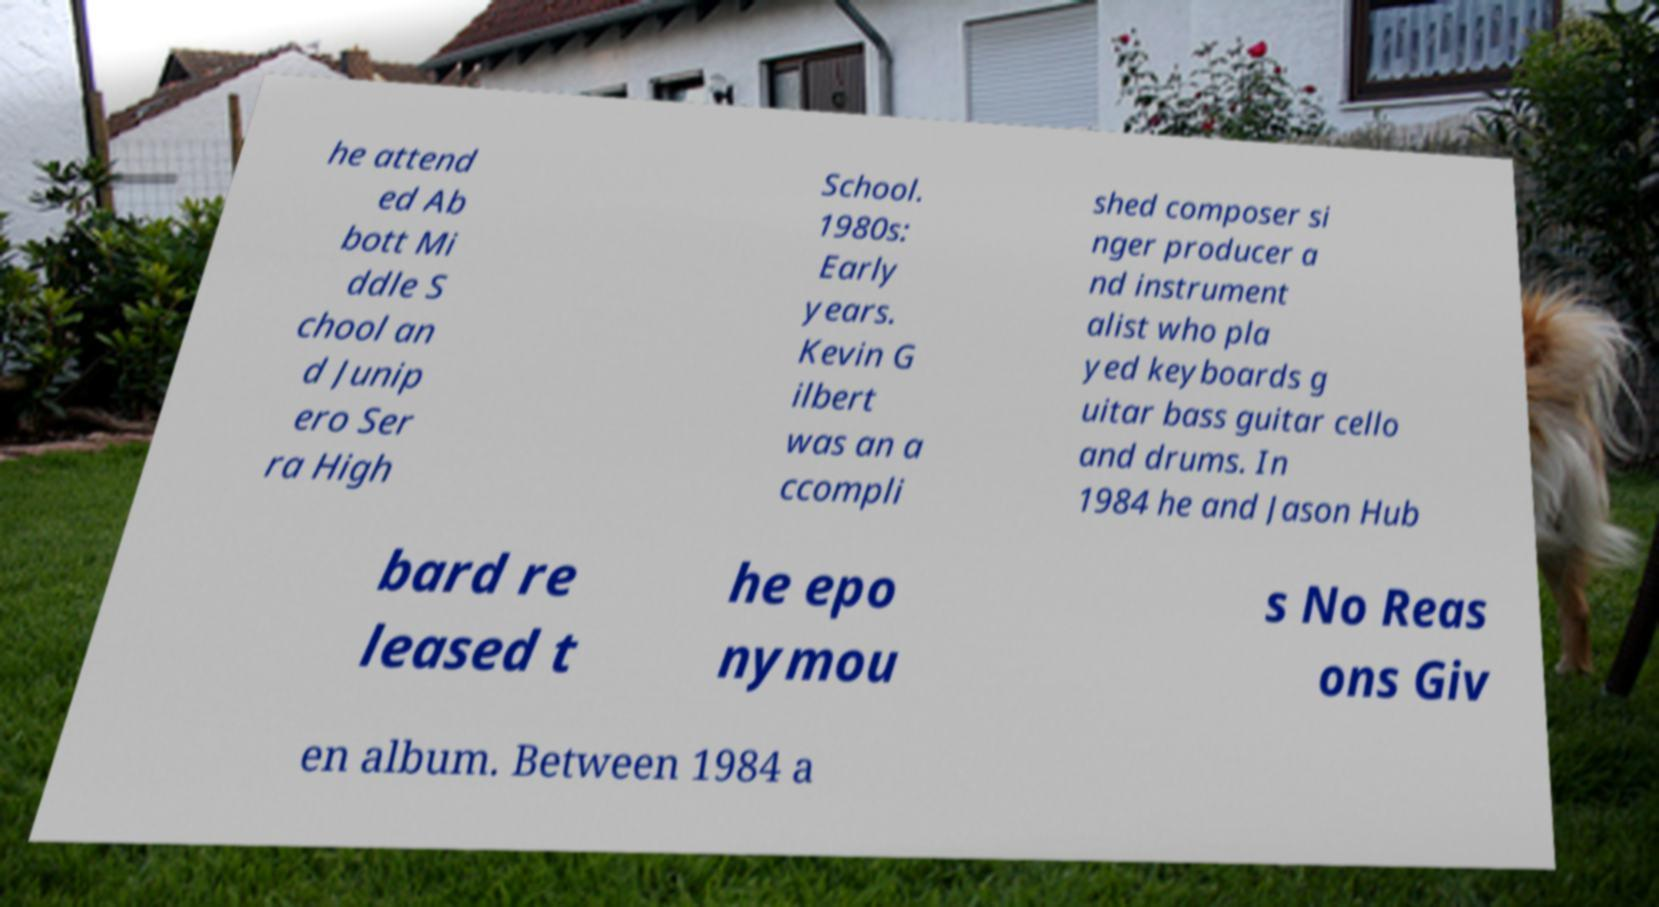Please read and relay the text visible in this image. What does it say? he attend ed Ab bott Mi ddle S chool an d Junip ero Ser ra High School. 1980s: Early years. Kevin G ilbert was an a ccompli shed composer si nger producer a nd instrument alist who pla yed keyboards g uitar bass guitar cello and drums. In 1984 he and Jason Hub bard re leased t he epo nymou s No Reas ons Giv en album. Between 1984 a 